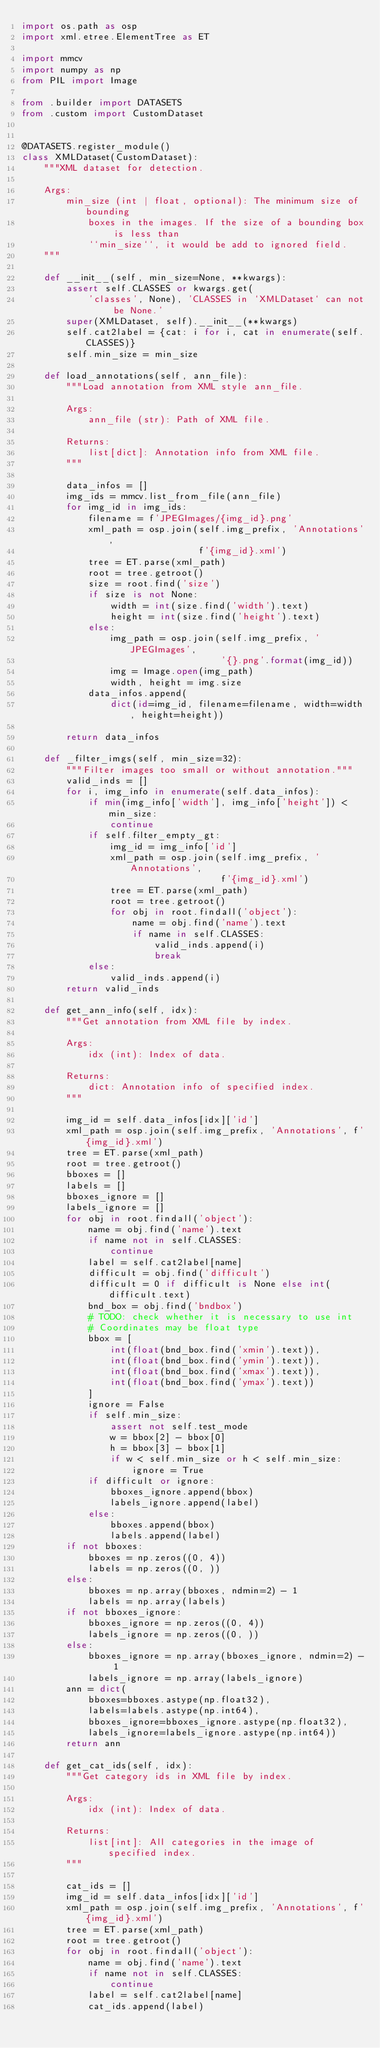<code> <loc_0><loc_0><loc_500><loc_500><_Python_>import os.path as osp
import xml.etree.ElementTree as ET

import mmcv
import numpy as np
from PIL import Image

from .builder import DATASETS
from .custom import CustomDataset


@DATASETS.register_module()
class XMLDataset(CustomDataset):
    """XML dataset for detection.

    Args:
        min_size (int | float, optional): The minimum size of bounding
            boxes in the images. If the size of a bounding box is less than
            ``min_size``, it would be add to ignored field.
    """

    def __init__(self, min_size=None, **kwargs):
        assert self.CLASSES or kwargs.get(
            'classes', None), 'CLASSES in `XMLDataset` can not be None.'
        super(XMLDataset, self).__init__(**kwargs)
        self.cat2label = {cat: i for i, cat in enumerate(self.CLASSES)}
        self.min_size = min_size

    def load_annotations(self, ann_file):
        """Load annotation from XML style ann_file.

        Args:
            ann_file (str): Path of XML file.

        Returns:
            list[dict]: Annotation info from XML file.
        """

        data_infos = []
        img_ids = mmcv.list_from_file(ann_file)
        for img_id in img_ids:
            filename = f'JPEGImages/{img_id}.png'
            xml_path = osp.join(self.img_prefix, 'Annotations',
                                f'{img_id}.xml')
            tree = ET.parse(xml_path)
            root = tree.getroot()
            size = root.find('size')
            if size is not None:
                width = int(size.find('width').text)
                height = int(size.find('height').text)
            else:
                img_path = osp.join(self.img_prefix, 'JPEGImages',
                                    '{}.png'.format(img_id))
                img = Image.open(img_path)
                width, height = img.size
            data_infos.append(
                dict(id=img_id, filename=filename, width=width, height=height))

        return data_infos

    def _filter_imgs(self, min_size=32):
        """Filter images too small or without annotation."""
        valid_inds = []
        for i, img_info in enumerate(self.data_infos):
            if min(img_info['width'], img_info['height']) < min_size:
                continue
            if self.filter_empty_gt:
                img_id = img_info['id']
                xml_path = osp.join(self.img_prefix, 'Annotations',
                                    f'{img_id}.xml')
                tree = ET.parse(xml_path)
                root = tree.getroot()
                for obj in root.findall('object'):
                    name = obj.find('name').text
                    if name in self.CLASSES:
                        valid_inds.append(i)
                        break
            else:
                valid_inds.append(i)
        return valid_inds

    def get_ann_info(self, idx):
        """Get annotation from XML file by index.

        Args:
            idx (int): Index of data.

        Returns:
            dict: Annotation info of specified index.
        """

        img_id = self.data_infos[idx]['id']
        xml_path = osp.join(self.img_prefix, 'Annotations', f'{img_id}.xml')
        tree = ET.parse(xml_path)
        root = tree.getroot()
        bboxes = []
        labels = []
        bboxes_ignore = []
        labels_ignore = []
        for obj in root.findall('object'):
            name = obj.find('name').text
            if name not in self.CLASSES:
                continue
            label = self.cat2label[name]
            difficult = obj.find('difficult')
            difficult = 0 if difficult is None else int(difficult.text)
            bnd_box = obj.find('bndbox')
            # TODO: check whether it is necessary to use int
            # Coordinates may be float type
            bbox = [
                int(float(bnd_box.find('xmin').text)),
                int(float(bnd_box.find('ymin').text)),
                int(float(bnd_box.find('xmax').text)),
                int(float(bnd_box.find('ymax').text))
            ]
            ignore = False
            if self.min_size:
                assert not self.test_mode
                w = bbox[2] - bbox[0]
                h = bbox[3] - bbox[1]
                if w < self.min_size or h < self.min_size:
                    ignore = True
            if difficult or ignore:
                bboxes_ignore.append(bbox)
                labels_ignore.append(label)
            else:
                bboxes.append(bbox)
                labels.append(label)
        if not bboxes:
            bboxes = np.zeros((0, 4))
            labels = np.zeros((0, ))
        else:
            bboxes = np.array(bboxes, ndmin=2) - 1
            labels = np.array(labels)
        if not bboxes_ignore:
            bboxes_ignore = np.zeros((0, 4))
            labels_ignore = np.zeros((0, ))
        else:
            bboxes_ignore = np.array(bboxes_ignore, ndmin=2) - 1
            labels_ignore = np.array(labels_ignore)
        ann = dict(
            bboxes=bboxes.astype(np.float32),
            labels=labels.astype(np.int64),
            bboxes_ignore=bboxes_ignore.astype(np.float32),
            labels_ignore=labels_ignore.astype(np.int64))
        return ann

    def get_cat_ids(self, idx):
        """Get category ids in XML file by index.

        Args:
            idx (int): Index of data.

        Returns:
            list[int]: All categories in the image of specified index.
        """

        cat_ids = []
        img_id = self.data_infos[idx]['id']
        xml_path = osp.join(self.img_prefix, 'Annotations', f'{img_id}.xml')
        tree = ET.parse(xml_path)
        root = tree.getroot()
        for obj in root.findall('object'):
            name = obj.find('name').text
            if name not in self.CLASSES:
                continue
            label = self.cat2label[name]
            cat_ids.append(label)
</code> 